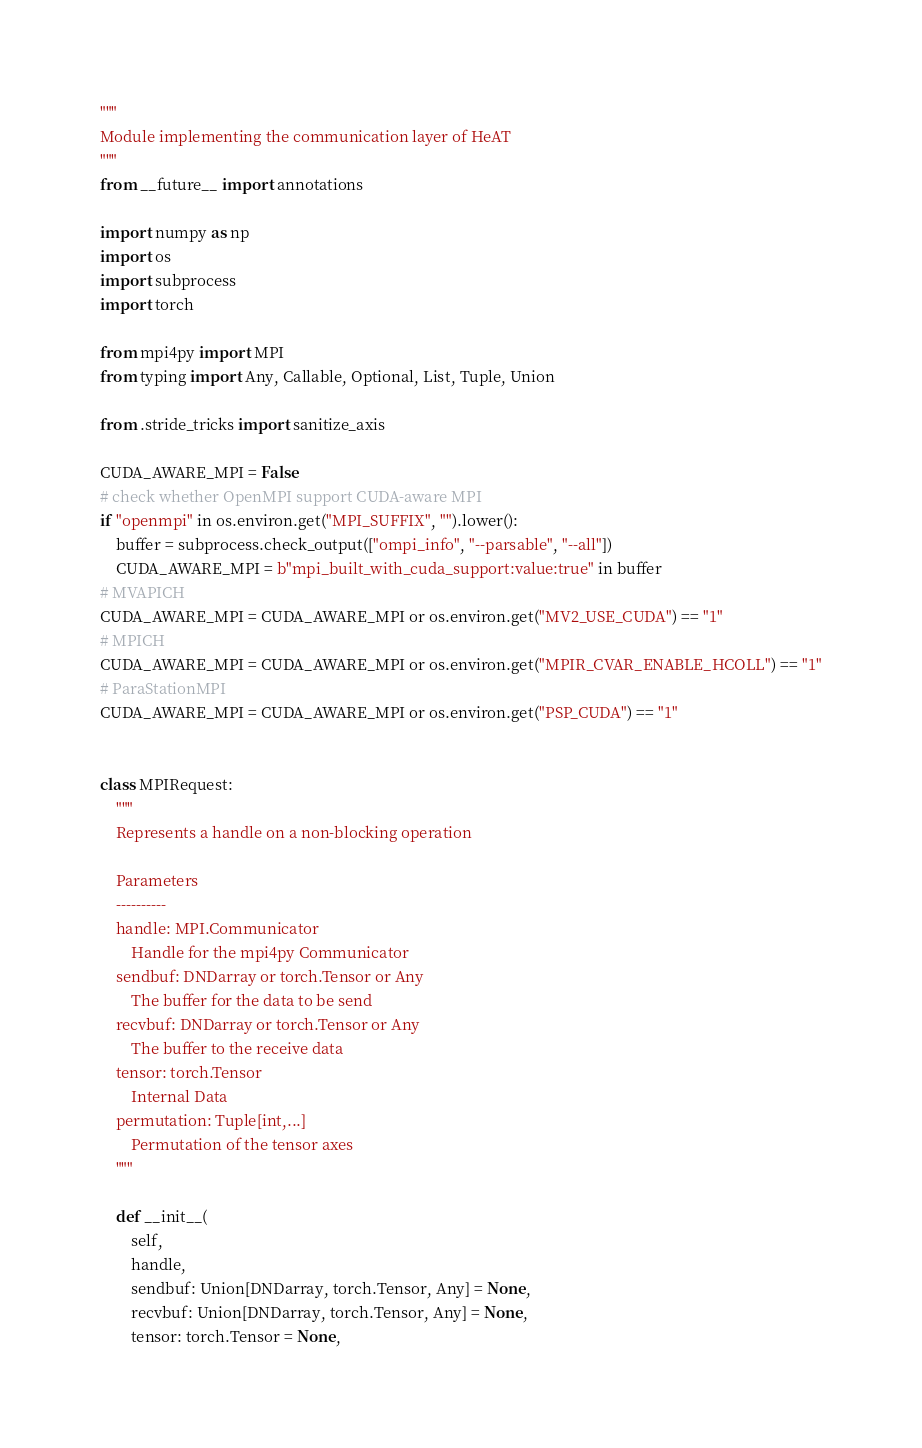Convert code to text. <code><loc_0><loc_0><loc_500><loc_500><_Python_>"""
Module implementing the communication layer of HeAT
"""
from __future__ import annotations

import numpy as np
import os
import subprocess
import torch

from mpi4py import MPI
from typing import Any, Callable, Optional, List, Tuple, Union

from .stride_tricks import sanitize_axis

CUDA_AWARE_MPI = False
# check whether OpenMPI support CUDA-aware MPI
if "openmpi" in os.environ.get("MPI_SUFFIX", "").lower():
    buffer = subprocess.check_output(["ompi_info", "--parsable", "--all"])
    CUDA_AWARE_MPI = b"mpi_built_with_cuda_support:value:true" in buffer
# MVAPICH
CUDA_AWARE_MPI = CUDA_AWARE_MPI or os.environ.get("MV2_USE_CUDA") == "1"
# MPICH
CUDA_AWARE_MPI = CUDA_AWARE_MPI or os.environ.get("MPIR_CVAR_ENABLE_HCOLL") == "1"
# ParaStationMPI
CUDA_AWARE_MPI = CUDA_AWARE_MPI or os.environ.get("PSP_CUDA") == "1"


class MPIRequest:
    """
    Represents a handle on a non-blocking operation

    Parameters
    ----------
    handle: MPI.Communicator
        Handle for the mpi4py Communicator
    sendbuf: DNDarray or torch.Tensor or Any
        The buffer for the data to be send
    recvbuf: DNDarray or torch.Tensor or Any
        The buffer to the receive data
    tensor: torch.Tensor
        Internal Data
    permutation: Tuple[int,...]
        Permutation of the tensor axes
    """

    def __init__(
        self,
        handle,
        sendbuf: Union[DNDarray, torch.Tensor, Any] = None,
        recvbuf: Union[DNDarray, torch.Tensor, Any] = None,
        tensor: torch.Tensor = None,</code> 